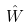<formula> <loc_0><loc_0><loc_500><loc_500>\hat { W }</formula> 